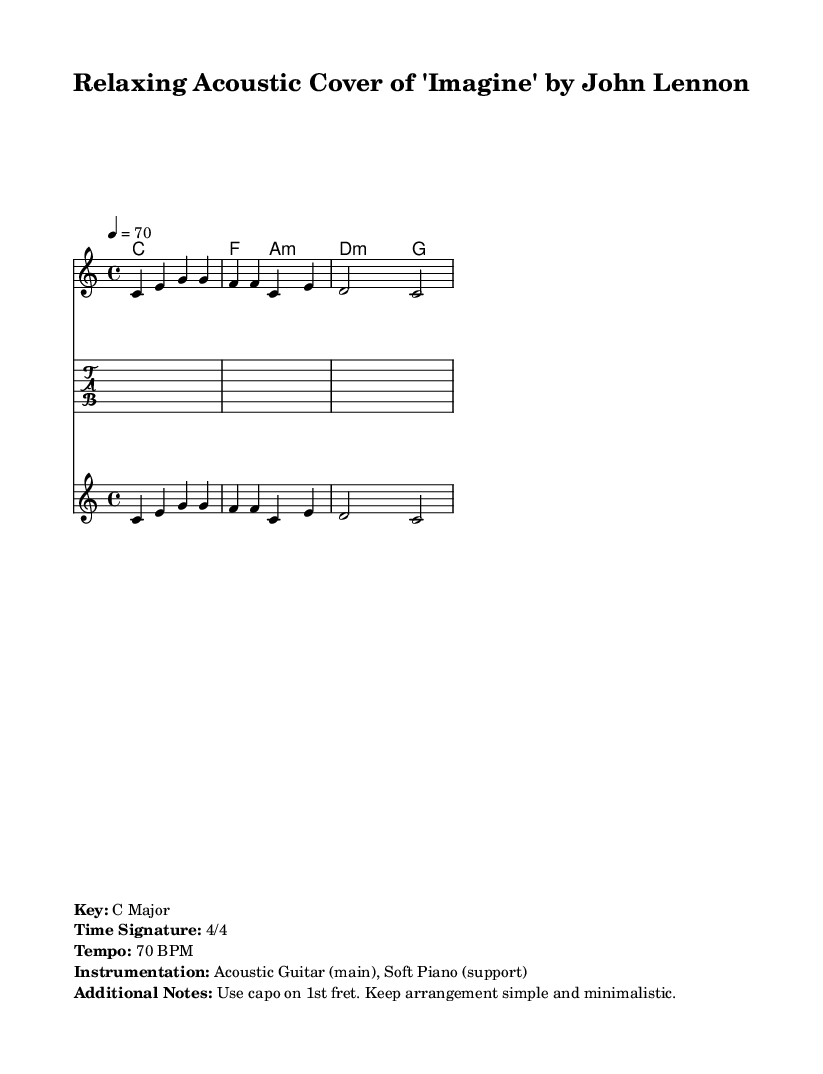What is the key signature of this music? The key signature is indicated in the global section of the code, specifying C major, which has no sharps or flats.
Answer: C Major What is the time signature of this music? The time signature is found in the global section of the code, written as 4/4, which means there are four beats per measure.
Answer: 4/4 What is the tempo marking for this piece? The tempo indicates the speed of the music and is provided in the global section of the code as 70 BPM (beats per minute).
Answer: 70 BPM How many measures are in the melody? The melody is divided into several segments, and by counting each set of notes in the provided melody section, there are four measures total.
Answer: 4 What instruments are used in this arrangement? The assigned instruments are mentioned in the markup section, specifying Acoustic Guitar as the main instrument and Soft Piano as support for the arrangement.
Answer: Acoustic Guitar (main), Soft Piano (support) What chord follows the C chord in the harmony? In the chord mode section, after the C chords, the next chords are F followed by A minor, implying that the F chord directly follows the C chord in the progression.
Answer: F What does "use capo on 1st fret" imply for performance? This instruction suggests that the guitarist should place a capo on the first fret of the guitar, which raises the pitch of all strings by one semitone, allowing for easier playing of the chords while maintaining the key of C major.
Answer: Use capo on 1st fret 